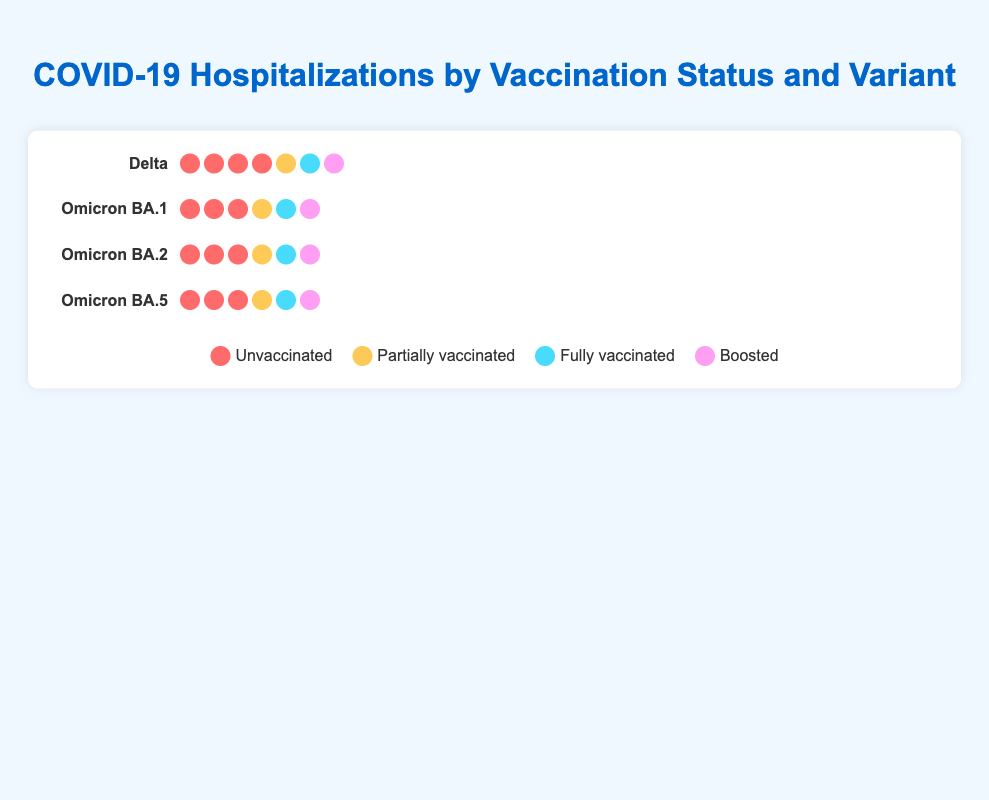What is the total number of hospitalizations for the Delta variant? To find the total number of hospitalizations for the Delta variant, sum the values for each vaccination status: 80 (Unvaccinated) + 15 (Partially vaccinated) + 10 (Fully vaccinated) + 5 (Boosted). Therefore, the total number of hospitalizations for the Delta variant is 110.
Answer: 110 Which variant has the highest number of unvaccinated hospitalizations? To determine which variant has the highest number of unvaccinated hospitalizations, compare the unvaccinated hospitalization numbers for each variant: Delta (80), Omicron BA.1 (60), Omicron BA.2 (50), Omicron BA.5 (45). Delta has the highest number of unvaccinated hospitalizations.
Answer: Delta How many more fully vaccinated hospitalizations are there for Omicron BA.1 compared to Omicron BA.5? To find the difference in fully vaccinated hospitalizations between Omicron BA.1 and Omicron BA.5, subtract the fully vaccinated hospitalizations of Omicron BA.5 (10) from those of Omicron BA.1 (15): 15 - 10 = 5. Therefore, there are 5 more fully vaccinated hospitalizations for Omicron BA.1 compared to Omicron BA.5.
Answer: 5 Which vaccination status has the lowest number of hospitalizations for Omicron BA.2? To determine which vaccination status has the lowest number of hospitalizations for Omicron BA.2, compare the hospitalizations: Unvaccinated (50), Partially vaccinated (18), Fully vaccinated (12), Boosted (6). Boosted has the lowest number of hospitalizations.
Answer: Boosted What is the ratio of boosted hospitalizations to unvaccinated hospitalizations for Omicron BA.5? To calculate the ratio of boosted hospitalizations to unvaccinated hospitalizations for Omicron BA.5, divide the number of boosted hospitalizations (5) by the number of unvaccinated hospitalizations (45): 5 / 45 = 1 / 9. Therefore, the ratio is 1:9.
Answer: 1:9 Between Delta and Omicron BA.1, which variant shows a greater reduction in hospitalizations for fully vaccinated individuals compared to unvaccinated individuals? To find which variant has a greater reduction in hospitalizations for fully vaccinated individuals compared to unvaccinated individuals, calculate the reduction for both variants:
Delta: 80 (Unvaccinated) - 10 (Fully vaccinated) = 70
Omicron BA.1: 60 (Unvaccinated) - 15 (Fully vaccinated) = 45
The Delta variant shows a greater reduction in hospitalizations.
Answer: Delta What's the total number of hospitalizations for the fully vaccinated across all variants? To find the total number of hospitalizations for the fully vaccinated across all variants, sum the values for each variant: Delta (10) + Omicron BA.1 (15) + Omicron BA.2 (12) + Omicron BA.5 (10). Therefore, the total number of hospitalizations for the fully vaccinated is 47.
Answer: 47 How many more hospitalizations are there in the unvaccinated group compared to the boosted group for the Omicron BA.1 variant? To find the difference in hospitalizations between the unvaccinated and boosted groups for Omicron BA.1, subtract the number of boosted hospitalizations (8) from the number of unvaccinated hospitalizations (60): 60 - 8 = 52. Therefore, there are 52 more hospitalizations in the unvaccinated group compared to the boosted group for Omicron BA.1.
Answer: 52 Which variant has the smallest difference in hospitalizations between the unvaccinated and fully vaccinated groups? To determine which variant has the smallest difference in hospitalizations between the unvaccinated and fully vaccinated groups, calculate the difference for each variant:
Delta: 80 - 10 = 70
Omicron BA.1: 60 - 15 = 45
Omicron BA.2: 50 - 12 = 38
Omicron BA.5: 45 - 10 = 35
Omicron BA.5 has the smallest difference.
Answer: Omicron BA.5 